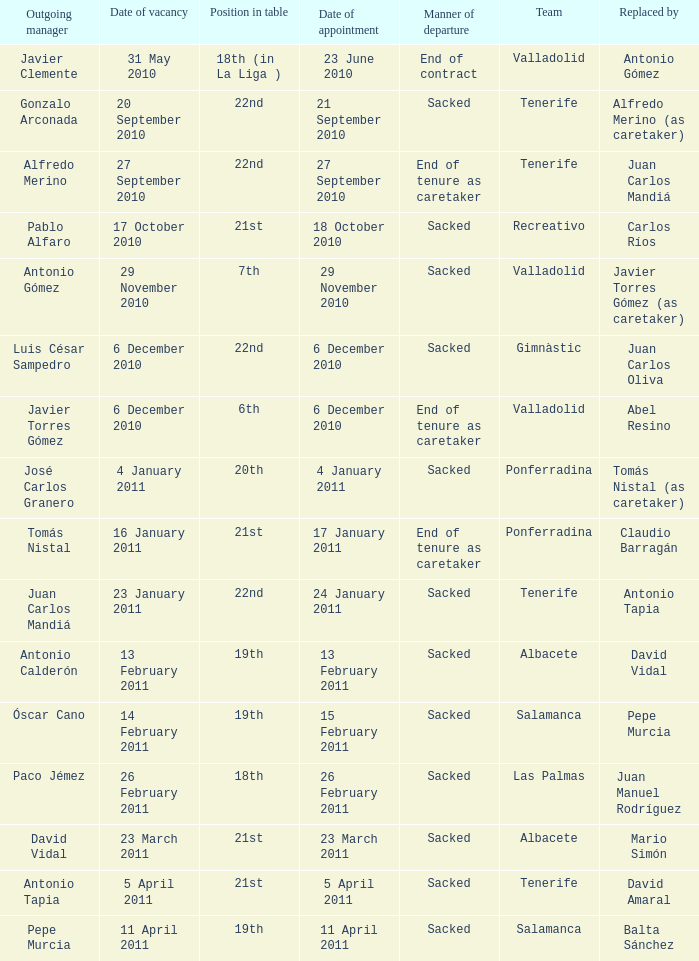How many teams had an appointment date of 11 april 2011 1.0. 